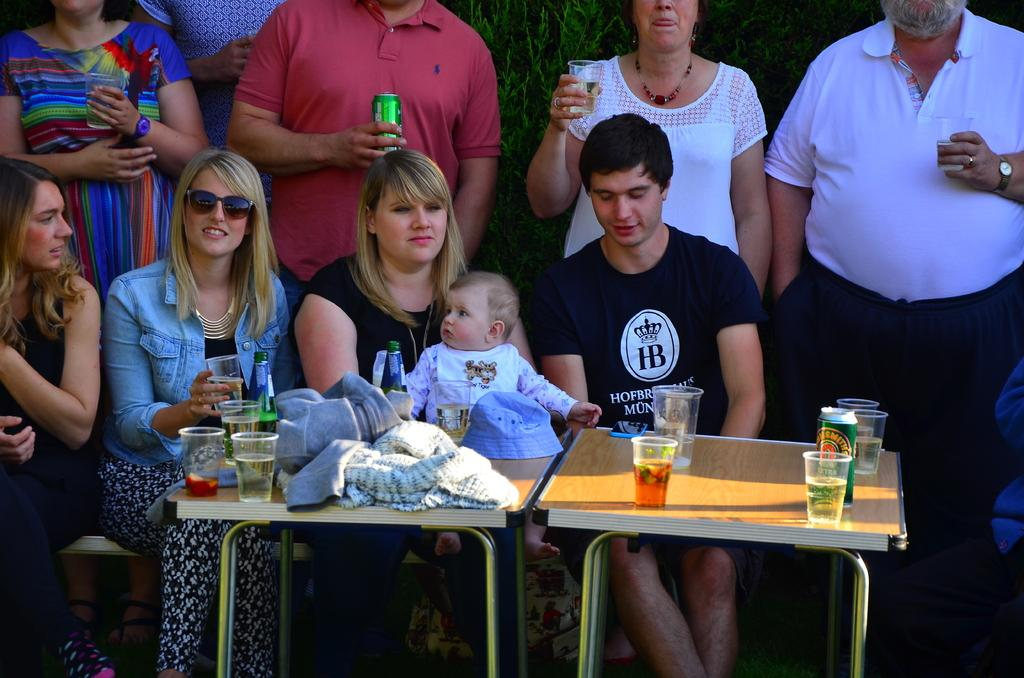How many people are present in the image? There are four people in the image. Can you describe the youngest person in the image? There is a baby in the image. Where are the people sitting in relation to the table? The people are sitting in front of a table. What can be found on the table in the image? The table has drinks on it. Are there any other people visible in the image? Yes, there are people standing behind the seated individuals. What type of mine can be seen in the background of the image? There is no mine present in the image; it features people sitting at a table with drinks. 